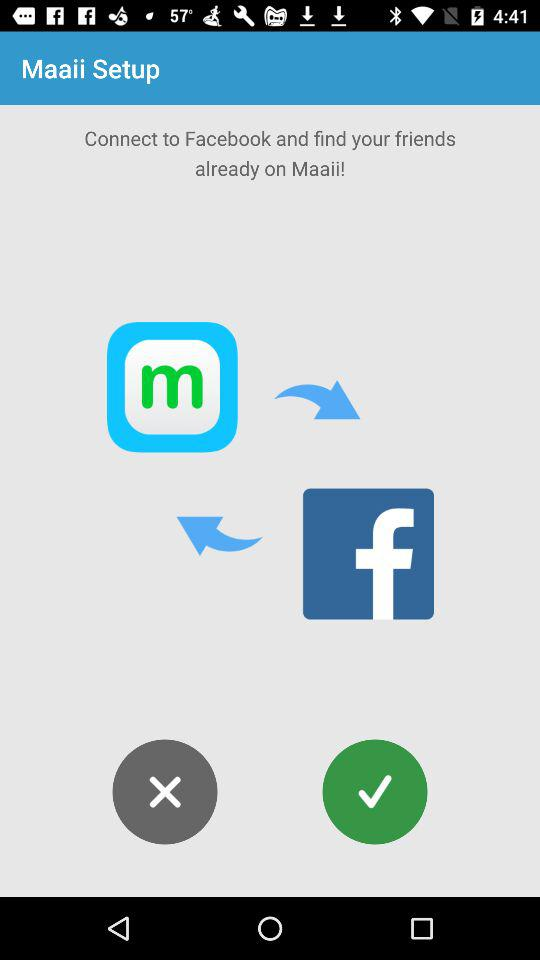What is the name of the application? The name of the application is "Maaii". 